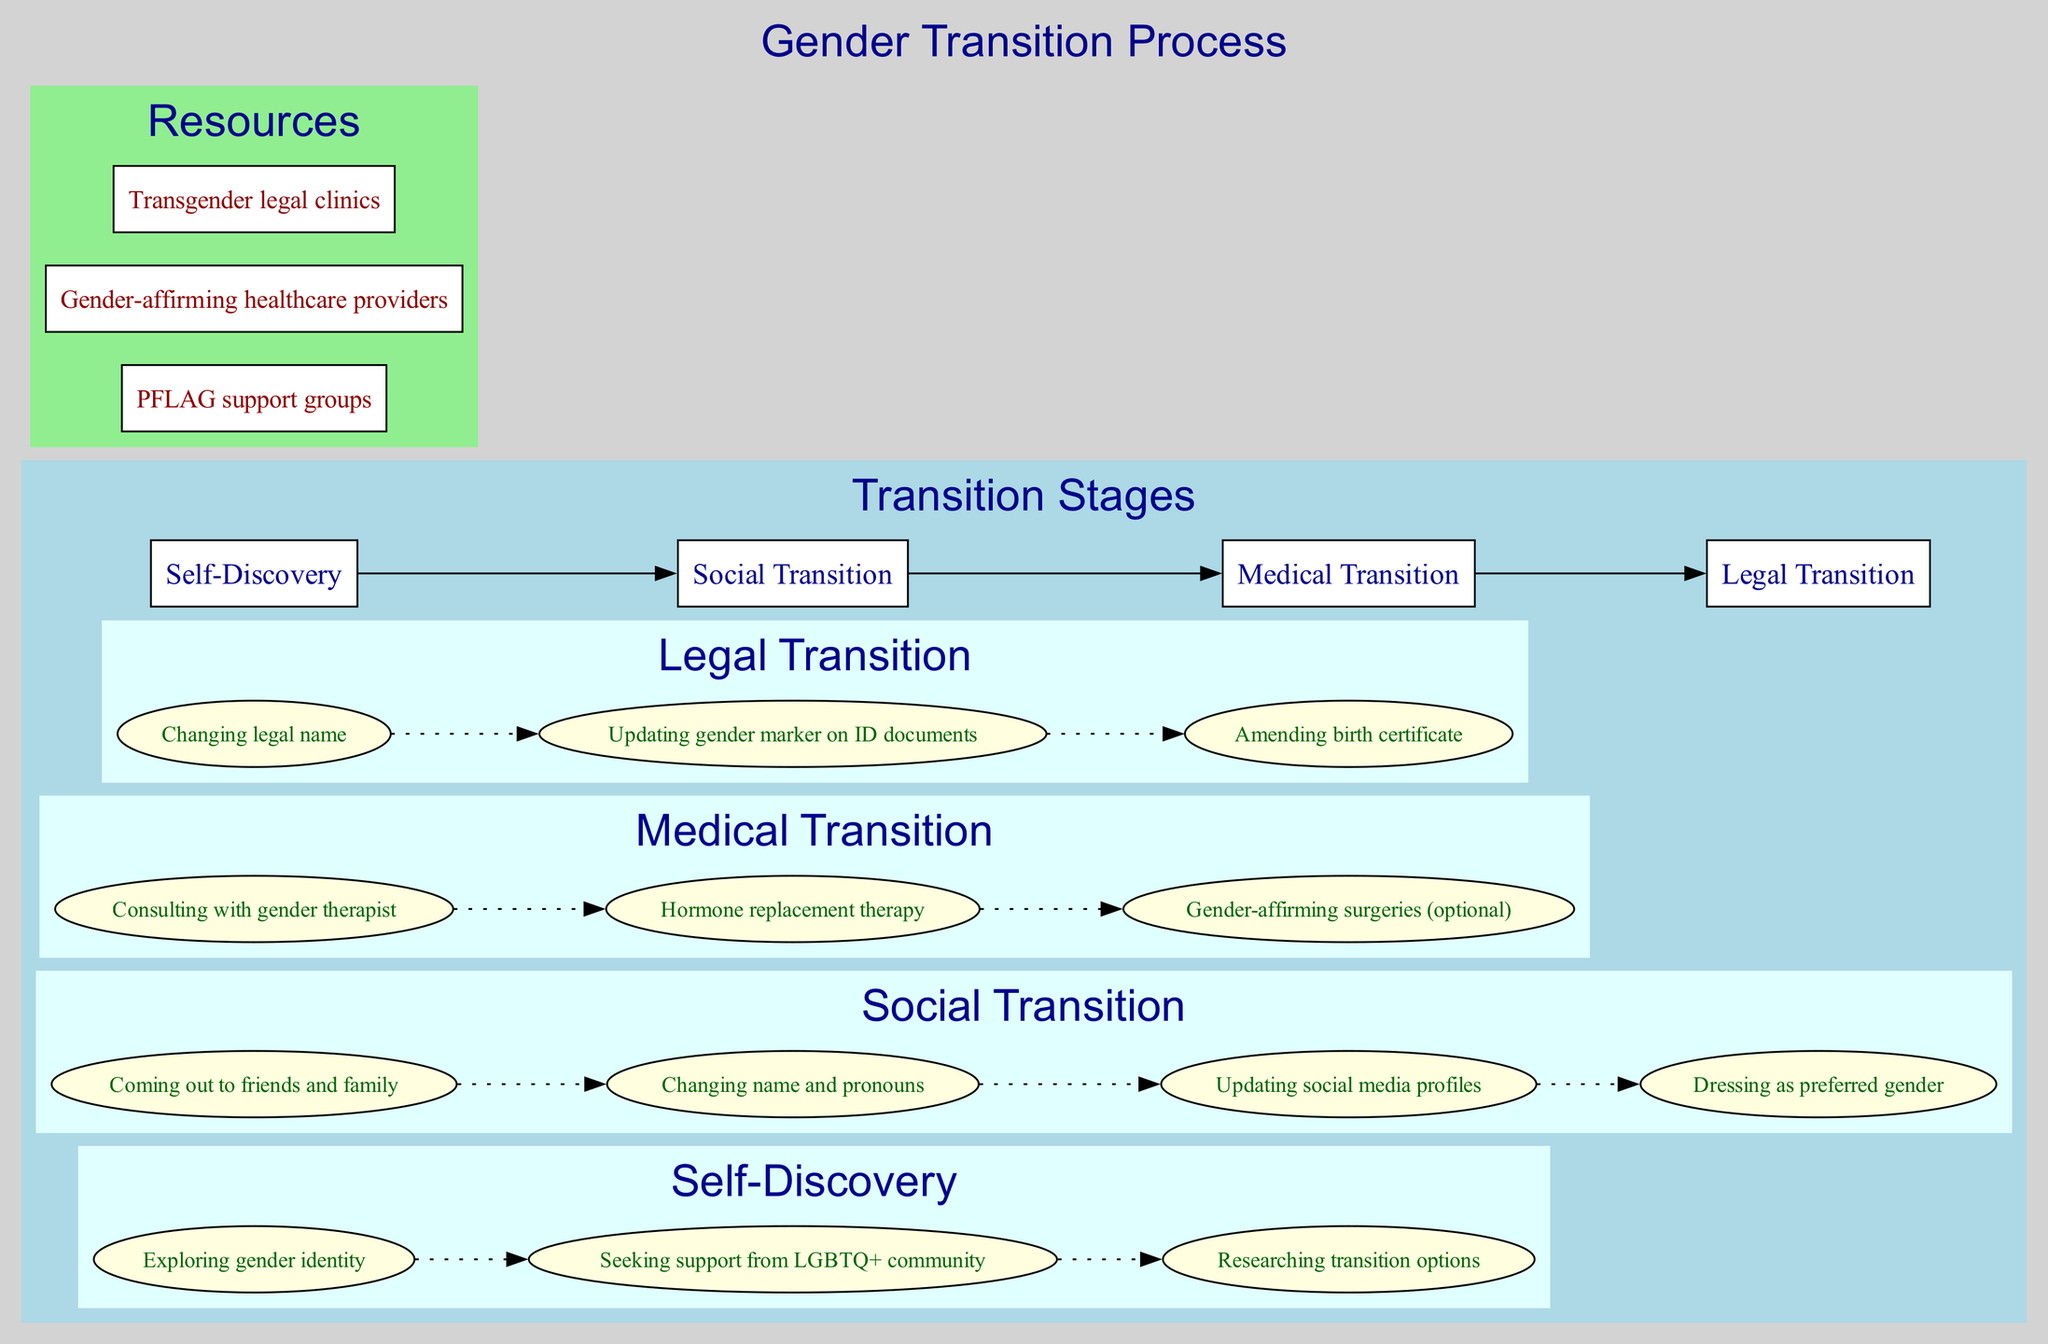What are the four main stages of the gender transition process? The diagram lists four main stages: Self-Discovery, Social Transition, Medical Transition, and Legal Transition. I locate these stages in the first part of the diagram, where each stage is clearly highlighted in a box.
Answer: Self-Discovery, Social Transition, Medical Transition, Legal Transition How many steps are in the Medical Transition stage? In the Medical Transition stage, there are three steps listed within the respective node. By counting the items under the Medical Transition section, I confirm that there are exactly three distinct steps.
Answer: 3 What is the first step in the Social Transition stage? The first step in the Social Transition stage is "Coming out to friends and family." This is visible in the list of steps provided under the Social Transition node.
Answer: Coming out to friends and family What is the relationship between the Self-Discovery and Social Transition stages? The diagram shows an edge connecting Self-Discovery to Social Transition, indicating that Self-Discovery is a precursor to leading into Social Transition. This visual cue signifies the progression from one stage to the next.
Answer: Self-Discovery leads to Social Transition How many resources are listed in the diagram? There are three resources indicated in the Resources section of the diagram. By counting the items under the Resources cluster, I arrive at the number three.
Answer: 3 Which step is directly followed by "Hormone replacement therapy" in the Medical Transition stage? The step "Hormone replacement therapy" is directly preceded by "Consulting with gender therapist," which is the first step listed under the Medical Transition stage. This is inferred from the visual order of the steps.
Answer: Consulting with gender therapist Which color represents the stages in the diagram? The stages in the diagram are represented by the color light blue. This is determined by the background color of the cluster that houses the stages, confirming its visual identity.
Answer: Light blue What is the final step in the Legal Transition stage? The final step listed in the Legal Transition stage is "Amending birth certificate." By reviewing the order in which the steps are presented, I identify that this is the last item in the sequence.
Answer: Amending birth certificate 